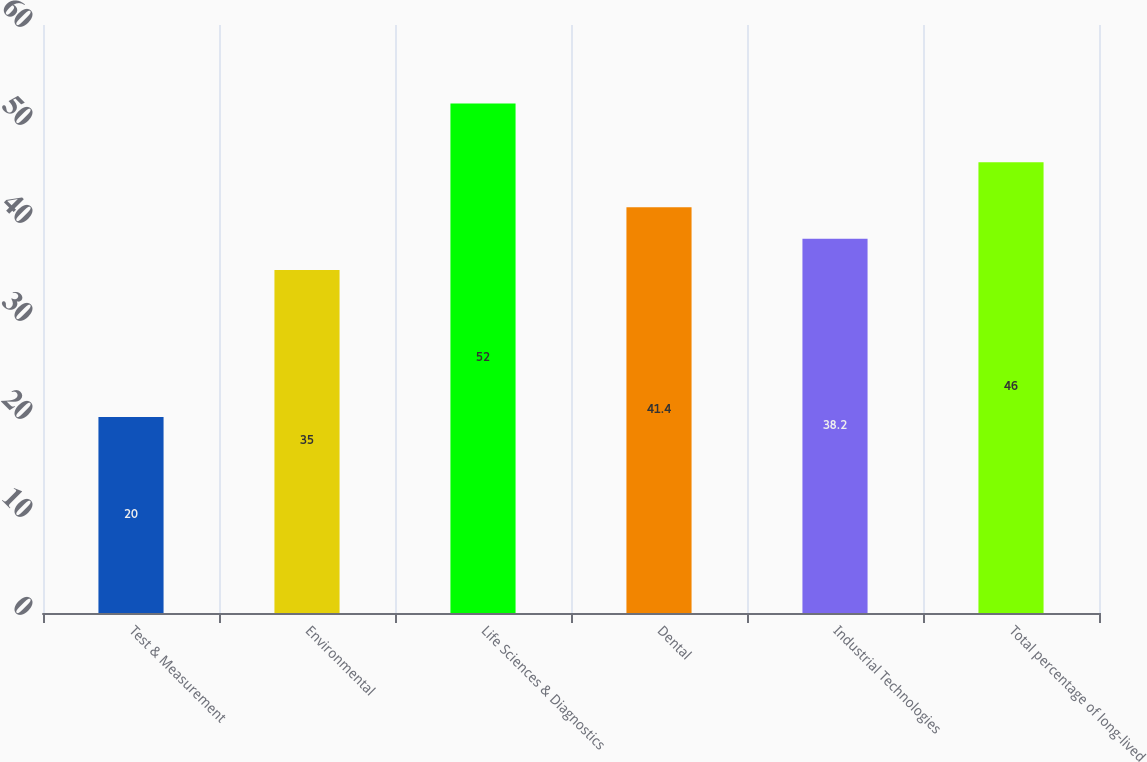<chart> <loc_0><loc_0><loc_500><loc_500><bar_chart><fcel>Test & Measurement<fcel>Environmental<fcel>Life Sciences & Diagnostics<fcel>Dental<fcel>Industrial Technologies<fcel>Total percentage of long-lived<nl><fcel>20<fcel>35<fcel>52<fcel>41.4<fcel>38.2<fcel>46<nl></chart> 